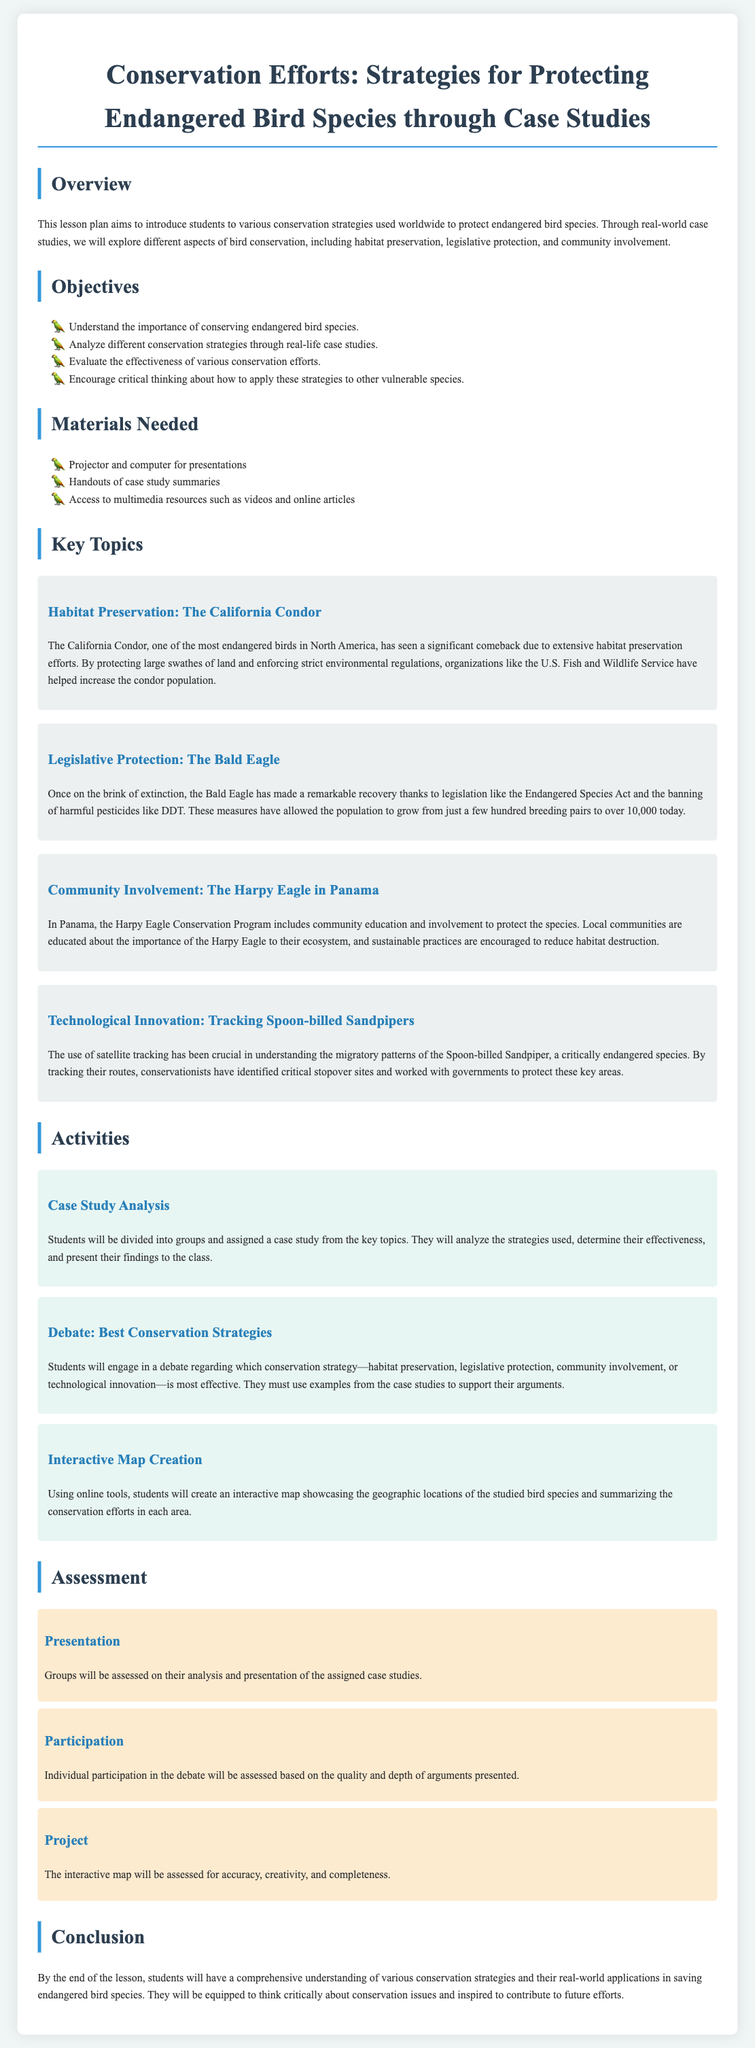What is the title of the lesson plan? The title of the lesson plan is prominently displayed at the top of the document.
Answer: Conservation Efforts: Strategies for Protecting Endangered Bird Species through Case Studies What is one objective of the lesson plan? The objectives are listed in a bulleted format under the Objectives section.
Answer: Analyze different conservation strategies through real-life case studies Which bird is associated with habitat preservation in the document? The specific bird is mentioned in the key topics discussing habitat preservation.
Answer: California Condor How many Bald Eagles were there after conservation measures? The document states the growth of the Bald Eagle population after conservation.
Answer: Over 10,000 What type of activity involves students presenting their findings? The activities section describes various interactive tasks for the students.
Answer: Case Study Analysis What is the method used to track Spoon-billed Sandpipers? The document specifies a technological approach used for this species.
Answer: Satellite tracking What does the interactive map project require from students? The specifics of the project outline the expectations of the student task.
Answer: Accuracy, creativity, and completeness What is a key topic that includes community involvement? The key topics feature specific cases of bird conservation that involve communities.
Answer: Harpy Eagle in Panama 